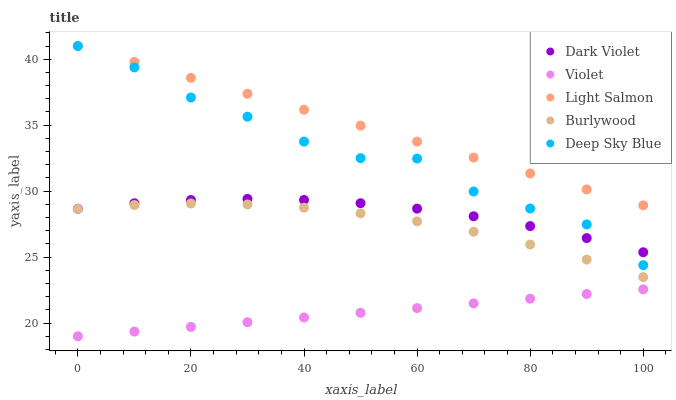Does Violet have the minimum area under the curve?
Answer yes or no. Yes. Does Light Salmon have the maximum area under the curve?
Answer yes or no. Yes. Does Deep Sky Blue have the minimum area under the curve?
Answer yes or no. No. Does Deep Sky Blue have the maximum area under the curve?
Answer yes or no. No. Is Violet the smoothest?
Answer yes or no. Yes. Is Deep Sky Blue the roughest?
Answer yes or no. Yes. Is Light Salmon the smoothest?
Answer yes or no. No. Is Light Salmon the roughest?
Answer yes or no. No. Does Violet have the lowest value?
Answer yes or no. Yes. Does Deep Sky Blue have the lowest value?
Answer yes or no. No. Does Deep Sky Blue have the highest value?
Answer yes or no. Yes. Does Dark Violet have the highest value?
Answer yes or no. No. Is Burlywood less than Light Salmon?
Answer yes or no. Yes. Is Light Salmon greater than Dark Violet?
Answer yes or no. Yes. Does Deep Sky Blue intersect Light Salmon?
Answer yes or no. Yes. Is Deep Sky Blue less than Light Salmon?
Answer yes or no. No. Is Deep Sky Blue greater than Light Salmon?
Answer yes or no. No. Does Burlywood intersect Light Salmon?
Answer yes or no. No. 